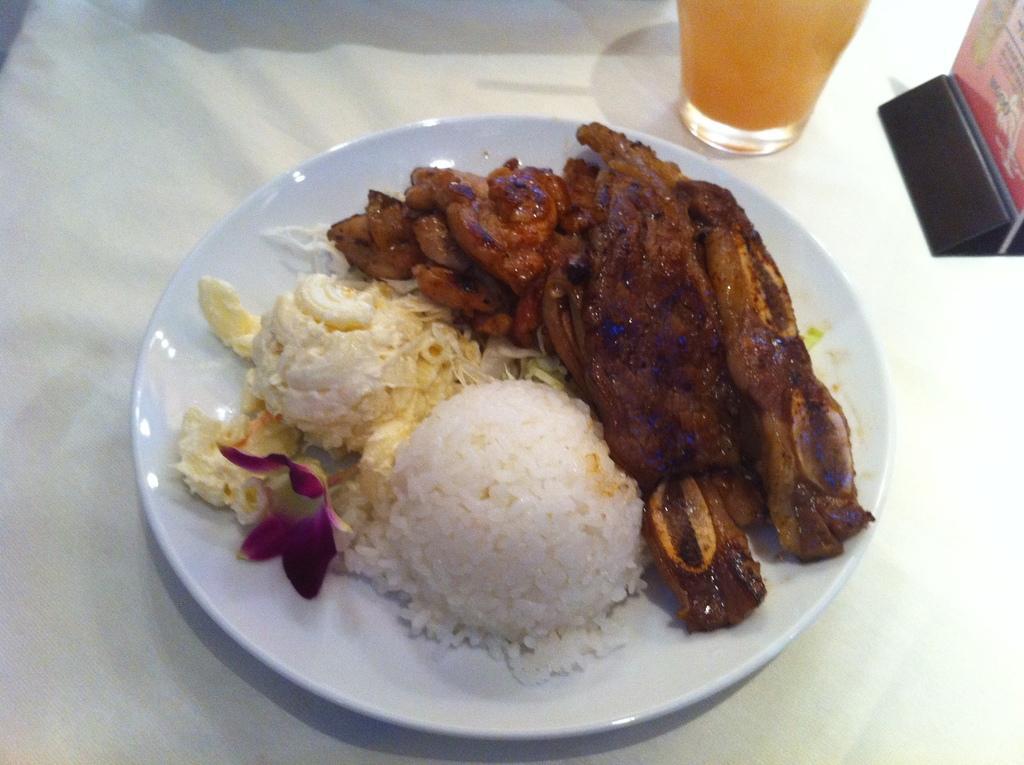Please provide a concise description of this image. In this image, we can see food items and flower on the white plate. This plate is placed on the white cloth. Top of the image, we can see a glass and few object. 